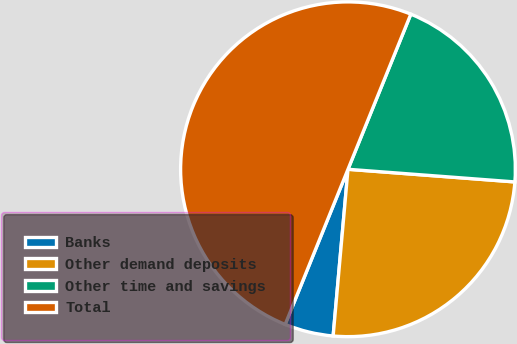Convert chart. <chart><loc_0><loc_0><loc_500><loc_500><pie_chart><fcel>Banks<fcel>Other demand deposits<fcel>Other time and savings<fcel>Total<nl><fcel>4.71%<fcel>25.21%<fcel>20.08%<fcel>50.0%<nl></chart> 